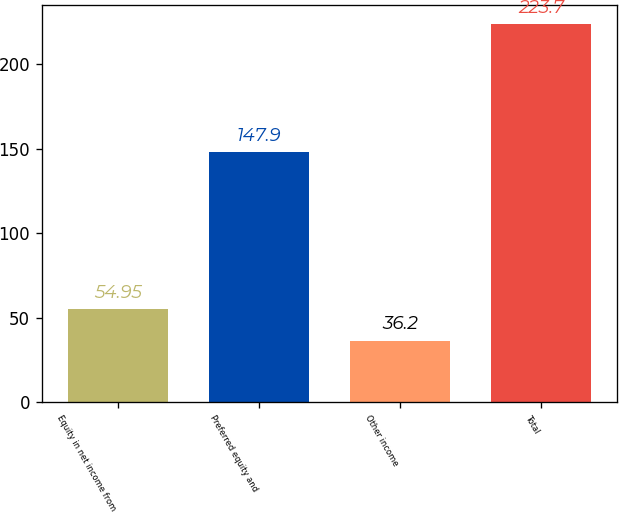Convert chart. <chart><loc_0><loc_0><loc_500><loc_500><bar_chart><fcel>Equity in net income from<fcel>Preferred equity and<fcel>Other income<fcel>Total<nl><fcel>54.95<fcel>147.9<fcel>36.2<fcel>223.7<nl></chart> 